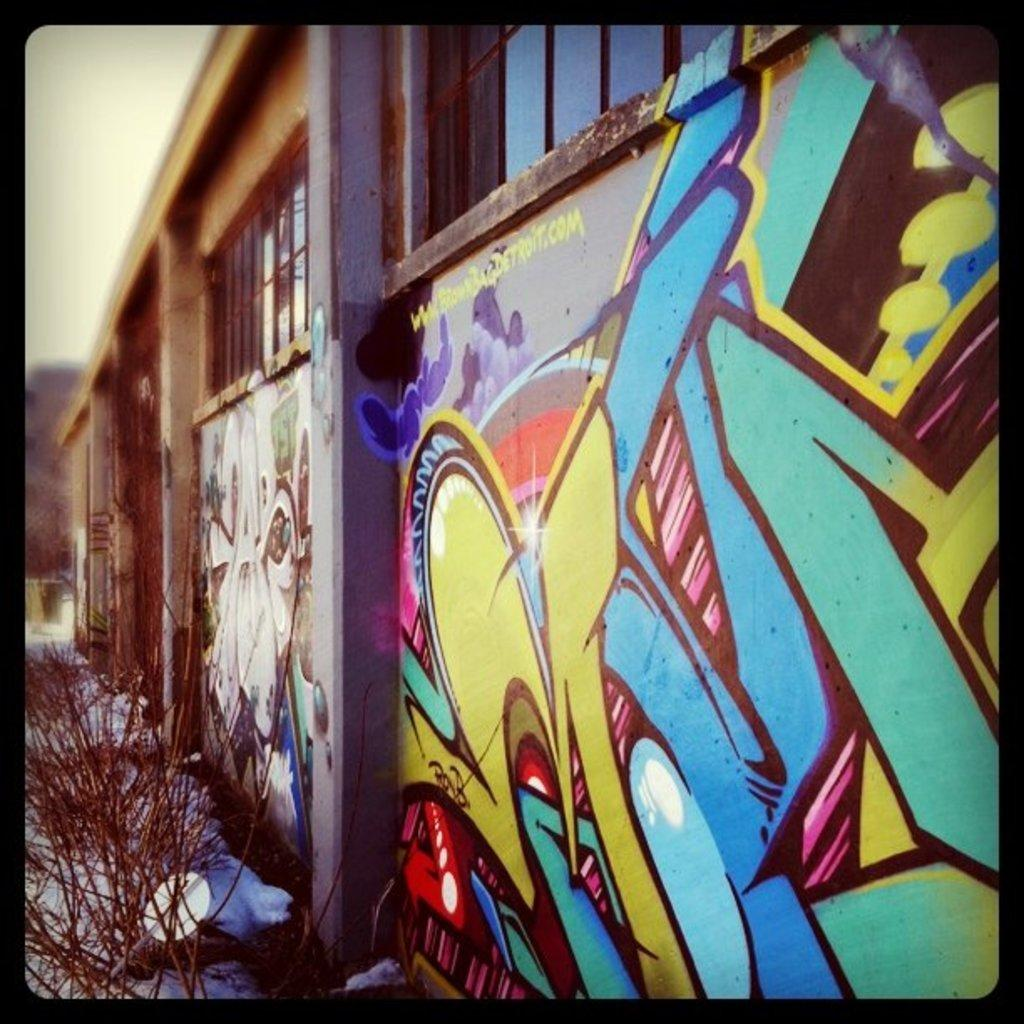What is depicted on the wall of the building in the image? There is graffiti on the wall of a building in the image. What else can be seen in the image besides the graffiti? There is a plant visible in the image. In what direction is the cable running in the image? There is no cable present in the image. 